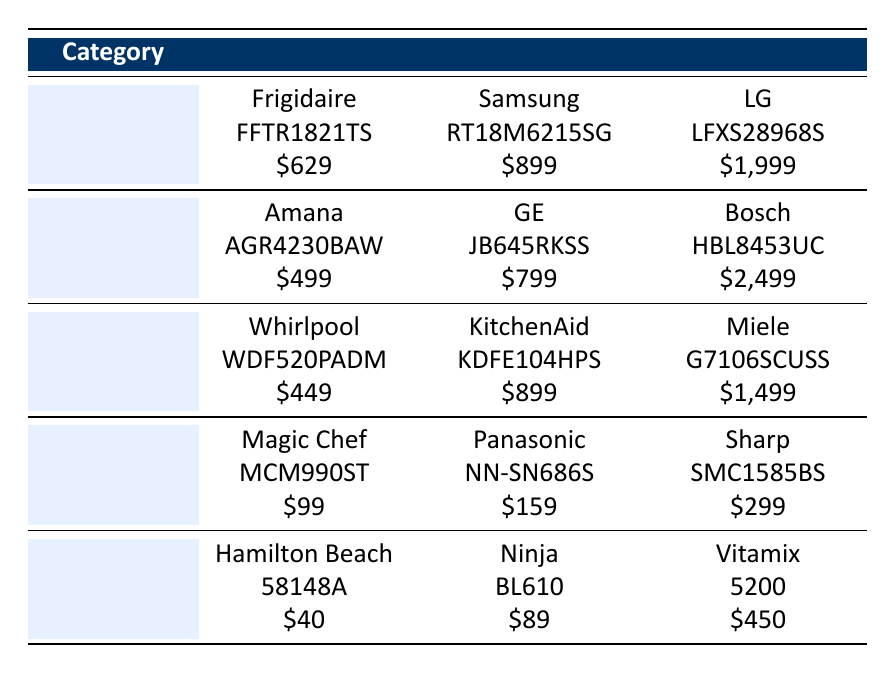What is the cost of the basic model refrigerator? The table indicates that the basic model refrigerator, Frigidaire FFTR1821TS, costs $629.
Answer: $629 Which oven model is the most expensive? By examining the table, the high-end oven model Bosch HBL8453UC has the highest cost at $2,499.
Answer: Bosch HBL8453UC What is the difference in cost between the basic and mid-range models of the dishwasher? The basic model, Whirlpool WDF520PADM, costs $449, while the mid-range model, KitchenAid KDFE104HPS, costs $899. The difference is $899 - $449 = $450.
Answer: $450 Is the high-end microwave more expensive than the mid-range blender? The high-end microwave, Sharp SMC1585BS, costs $299, and the mid-range blender, Ninja BL610, costs $89. Since $299 is greater than $89, the statement is true.
Answer: Yes What is the total cost of all basic model appliances? The basic model costs for the appliances are $629 (refrigerator) + $499 (oven) + $449 (dishwasher) + $99 (microwave) + $40 (blender), which sums up to $629 + $499 + $449 + $99 + $40 = $1716.
Answer: $1716 What is the average cost of the mid-range models across all categories? The mid-range model costs are $899 (refrigerator) + $799 (oven) + $899 (dishwasher) + $159 (microwave) + $89 (blender). Summing these gives $899 + $799 + $899 + $159 + $89 = $2845. Dividing by 5 (the number of categories) gives an average cost of $2845 / 5 = $569.
Answer: $569 Which appliance has the lowest cost across all models? Looking through the table, the lowest cost is found in the basic model microwave, Magic Chef MCM990ST, which costs $99.
Answer: $99 Are all mid-range model costs above $150? The mid-range model costs are $899 (refrigerator), $799 (oven), $899 (dishwasher), $159 (microwave), and $89 (blender). Since $89 is not above $150, the statement is false.
Answer: No What is the most expensive high-end appliance? Upon reviewing the table, the high-end oven Bosch HBL8453UC costs $2,499, which is the highest among the high-end appliances listed.
Answer: Bosch HBL8453UC 